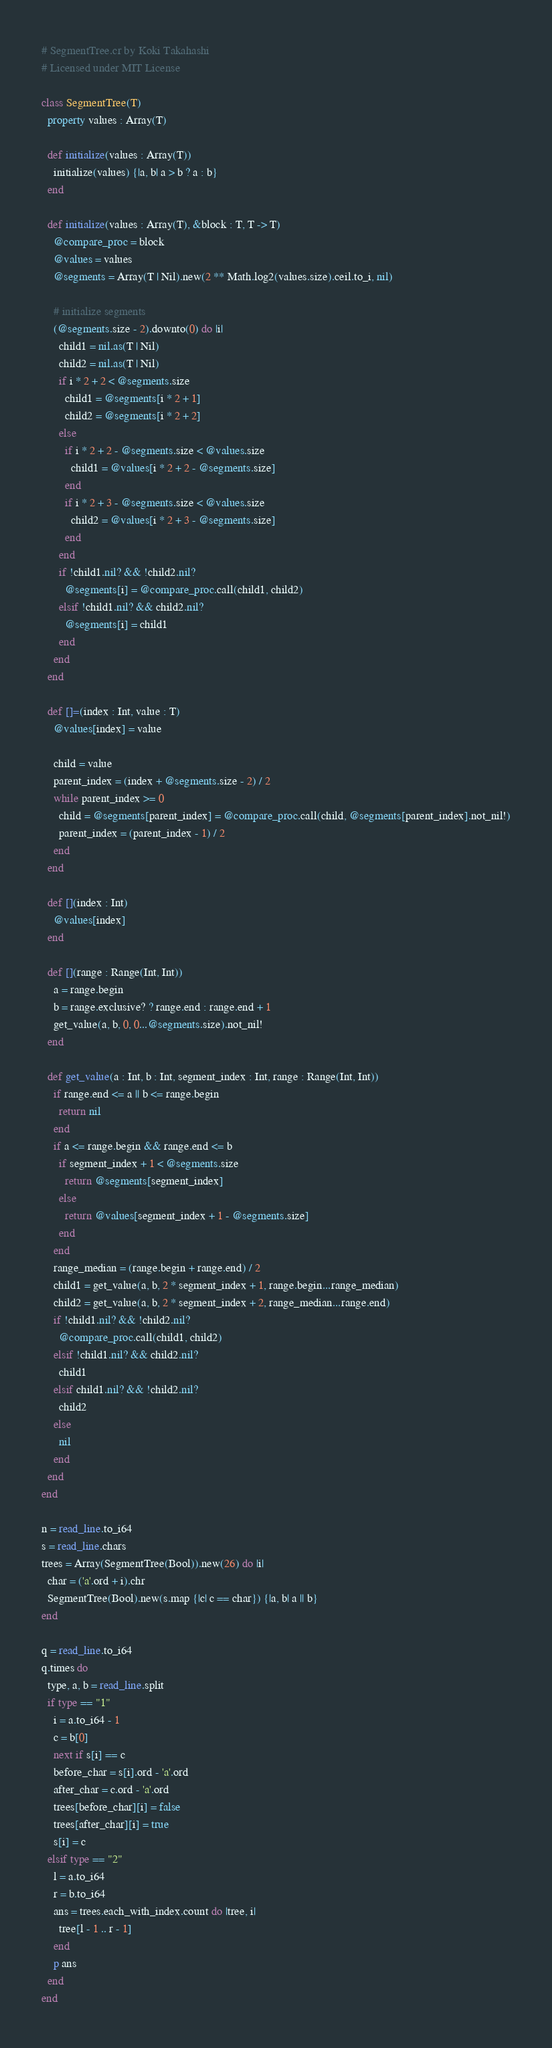Convert code to text. <code><loc_0><loc_0><loc_500><loc_500><_Crystal_># SegmentTree.cr by Koki Takahashi
# Licensed under MIT License

class SegmentTree(T)
  property values : Array(T)

  def initialize(values : Array(T))
    initialize(values) {|a, b| a > b ? a : b}
  end

  def initialize(values : Array(T), &block : T, T -> T)
    @compare_proc = block
    @values = values
    @segments = Array(T | Nil).new(2 ** Math.log2(values.size).ceil.to_i, nil)

    # initialize segments
    (@segments.size - 2).downto(0) do |i|
      child1 = nil.as(T | Nil)
      child2 = nil.as(T | Nil)
      if i * 2 + 2 < @segments.size
        child1 = @segments[i * 2 + 1]
        child2 = @segments[i * 2 + 2]
      else
        if i * 2 + 2 - @segments.size < @values.size
          child1 = @values[i * 2 + 2 - @segments.size]
        end
        if i * 2 + 3 - @segments.size < @values.size
          child2 = @values[i * 2 + 3 - @segments.size]
        end
      end
      if !child1.nil? && !child2.nil?
        @segments[i] = @compare_proc.call(child1, child2)
      elsif !child1.nil? && child2.nil?
        @segments[i] = child1
      end
    end
  end

  def []=(index : Int, value : T)
    @values[index] = value

    child = value
    parent_index = (index + @segments.size - 2) / 2
    while parent_index >= 0
      child = @segments[parent_index] = @compare_proc.call(child, @segments[parent_index].not_nil!)
      parent_index = (parent_index - 1) / 2
    end
  end

  def [](index : Int)
    @values[index]
  end

  def [](range : Range(Int, Int))
    a = range.begin
    b = range.exclusive? ? range.end : range.end + 1
    get_value(a, b, 0, 0...@segments.size).not_nil!
  end

  def get_value(a : Int, b : Int, segment_index : Int, range : Range(Int, Int))
    if range.end <= a || b <= range.begin
      return nil
    end
    if a <= range.begin && range.end <= b
      if segment_index + 1 < @segments.size
        return @segments[segment_index]
      else
        return @values[segment_index + 1 - @segments.size]
      end
    end
    range_median = (range.begin + range.end) / 2
    child1 = get_value(a, b, 2 * segment_index + 1, range.begin...range_median)
    child2 = get_value(a, b, 2 * segment_index + 2, range_median...range.end)
    if !child1.nil? && !child2.nil?
      @compare_proc.call(child1, child2)
    elsif !child1.nil? && child2.nil?
      child1
    elsif child1.nil? && !child2.nil?
      child2
    else
      nil
    end
  end
end

n = read_line.to_i64
s = read_line.chars
trees = Array(SegmentTree(Bool)).new(26) do |i|
  char = ('a'.ord + i).chr
  SegmentTree(Bool).new(s.map {|c| c == char}) {|a, b| a || b}
end

q = read_line.to_i64
q.times do
  type, a, b = read_line.split
  if type == "1"
    i = a.to_i64 - 1
    c = b[0]
    next if s[i] == c
    before_char = s[i].ord - 'a'.ord
    after_char = c.ord - 'a'.ord
    trees[before_char][i] = false
    trees[after_char][i] = true
    s[i] = c
  elsif type == "2"
    l = a.to_i64
    r = b.to_i64
    ans = trees.each_with_index.count do |tree, i|
      tree[l - 1 .. r - 1]
    end
    p ans
  end
end</code> 